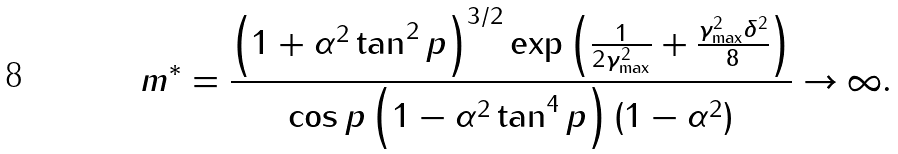<formula> <loc_0><loc_0><loc_500><loc_500>m ^ { * } = \frac { \left ( 1 + \alpha ^ { 2 } \tan ^ { 2 } { p } \right ) ^ { 3 / 2 } \exp \left ( \frac { 1 } { 2 \gamma _ { \max } ^ { 2 } } + \frac { \gamma _ { \max } ^ { 2 } \delta ^ { 2 } } { 8 } \right ) } { \cos { p } \left ( 1 - \alpha ^ { 2 } \tan ^ { 4 } { p } \right ) ( 1 - \alpha ^ { 2 } ) } \rightarrow \infty .</formula> 